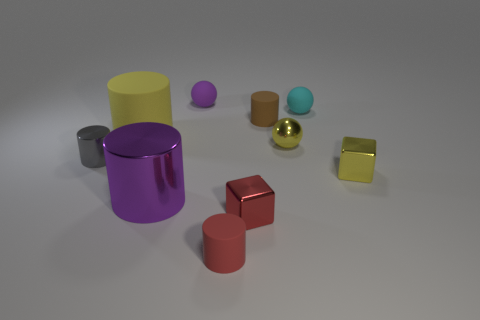Do the purple object in front of the purple rubber sphere and the red matte object have the same shape?
Provide a succinct answer. Yes. There is a small rubber ball in front of the purple matte object; is there a metallic sphere that is on the right side of it?
Your answer should be very brief. No. How many small brown matte cylinders are there?
Offer a very short reply. 1. There is a tiny ball that is both right of the tiny red matte thing and behind the large yellow cylinder; what color is it?
Your response must be concise. Cyan. The other metal thing that is the same shape as the red metallic object is what size?
Keep it short and to the point. Small. What number of red shiny objects are the same size as the red cube?
Offer a terse response. 0. What is the small brown cylinder made of?
Give a very brief answer. Rubber. There is a small yellow metallic sphere; are there any tiny shiny things right of it?
Give a very brief answer. Yes. What is the size of the brown cylinder that is the same material as the big yellow cylinder?
Your answer should be compact. Small. How many small metallic blocks are the same color as the large matte thing?
Your response must be concise. 1. 